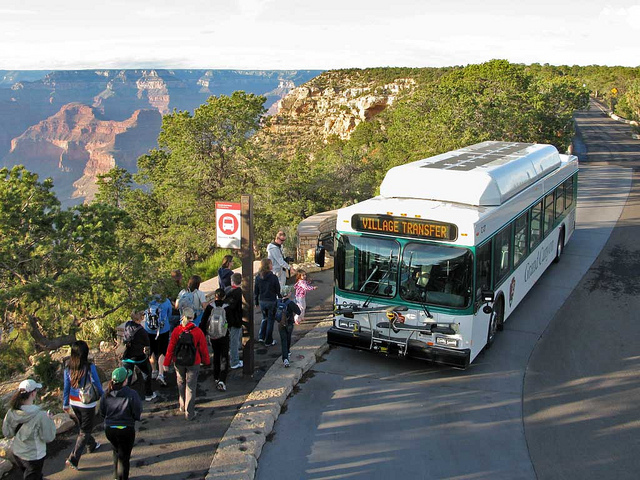Please extract the text content from this image. VILLAGE TRANSFER 